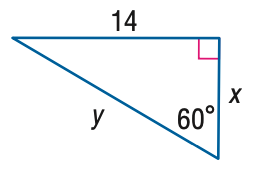Answer the mathemtical geometry problem and directly provide the correct option letter.
Question: Find x.
Choices: A: \frac { 14 \sqrt { 3 } } { 3 } B: 7 \sqrt { 2 } C: 14 D: 14 \sqrt { 3 } A 